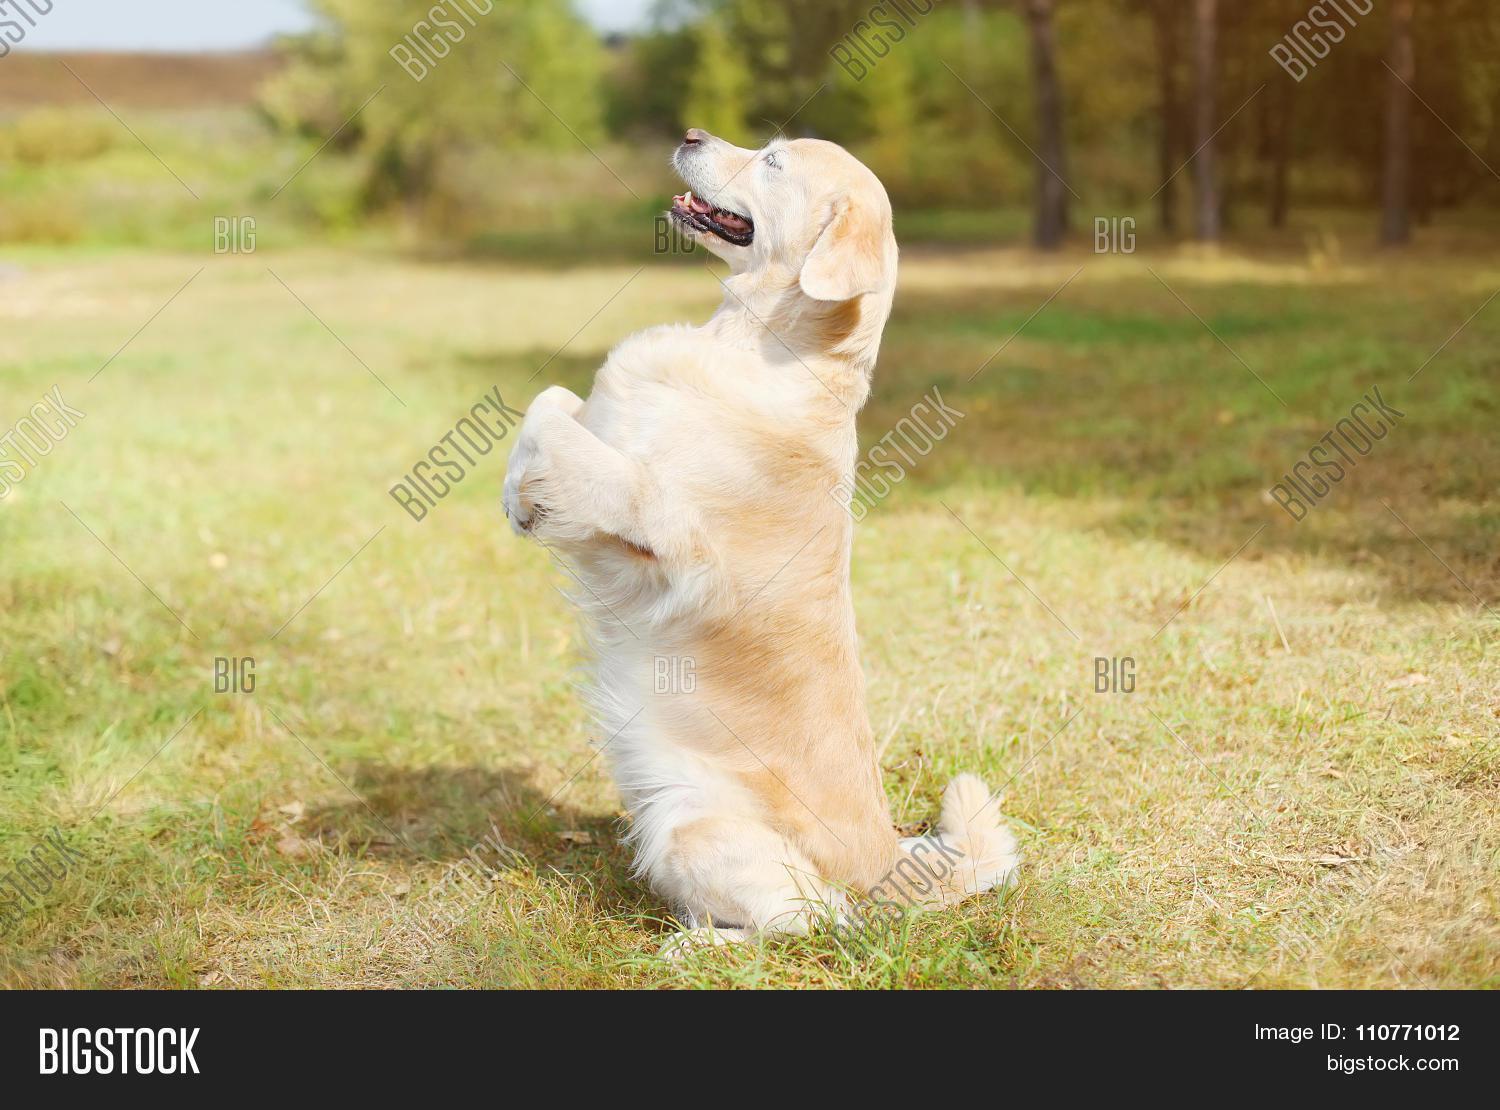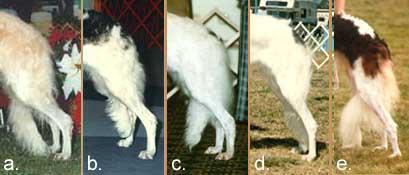The first image is the image on the left, the second image is the image on the right. Given the left and right images, does the statement "The dog in the image on the right is carrying something in its mouth." hold true? Answer yes or no. No. The first image is the image on the left, the second image is the image on the right. Examine the images to the left and right. Is the description "A dog that is mostly orange and a dog that is mostly white are together in a field covered with snow." accurate? Answer yes or no. No. 